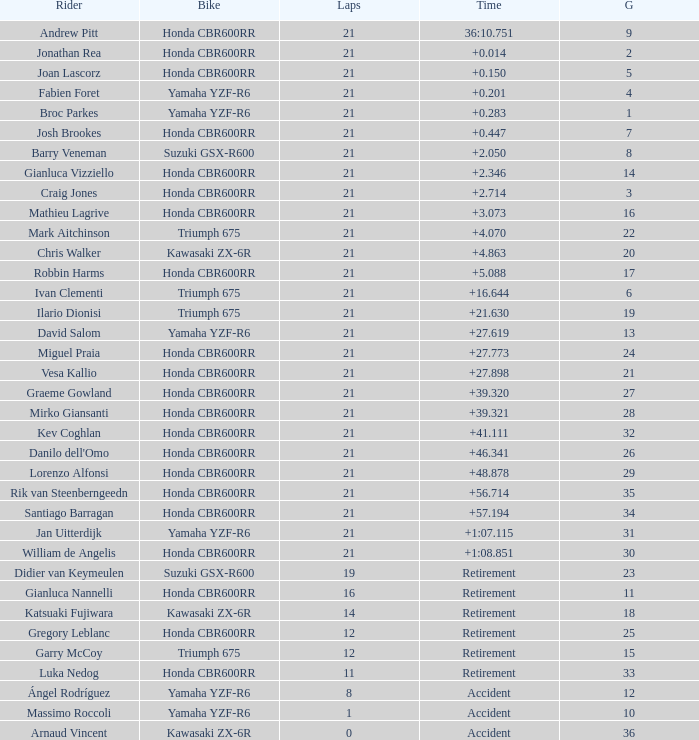Which driver completed fewer than 16 laps, began from the 10th spot on the grid, used a yamaha yzf-r6 motorcycle, and experienced a crash? Massimo Roccoli. 